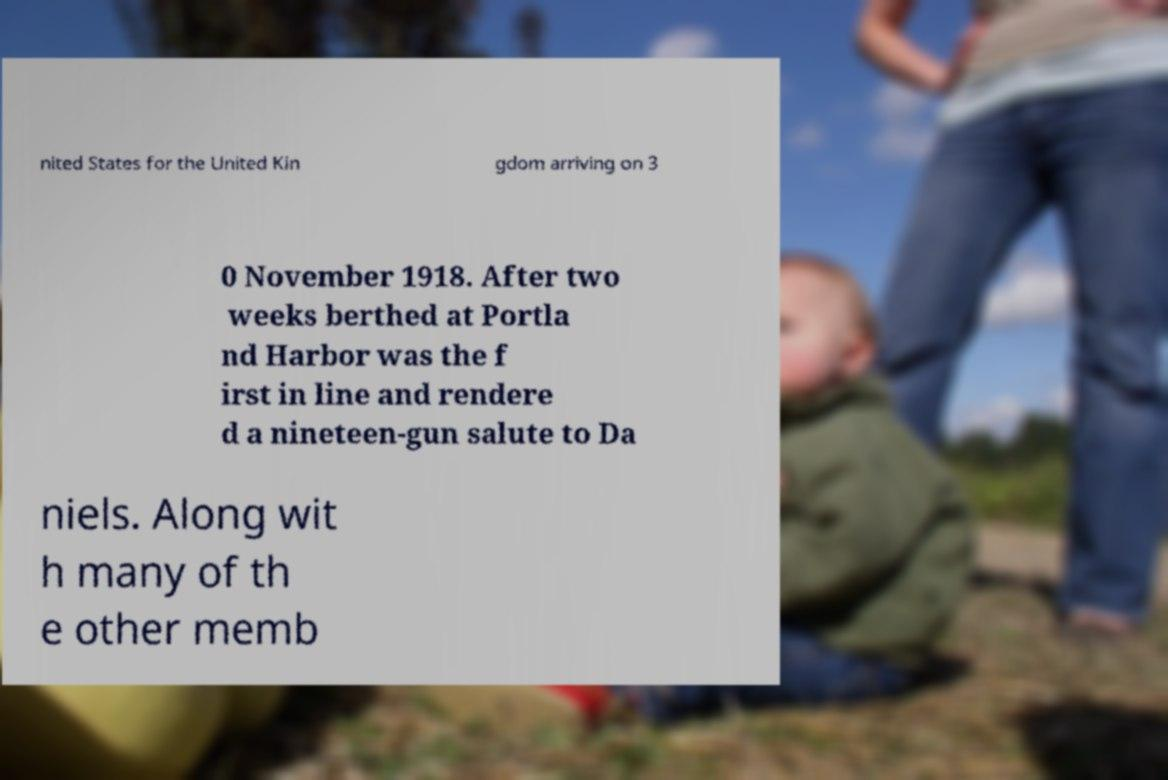Can you accurately transcribe the text from the provided image for me? nited States for the United Kin gdom arriving on 3 0 November 1918. After two weeks berthed at Portla nd Harbor was the f irst in line and rendere d a nineteen-gun salute to Da niels. Along wit h many of th e other memb 